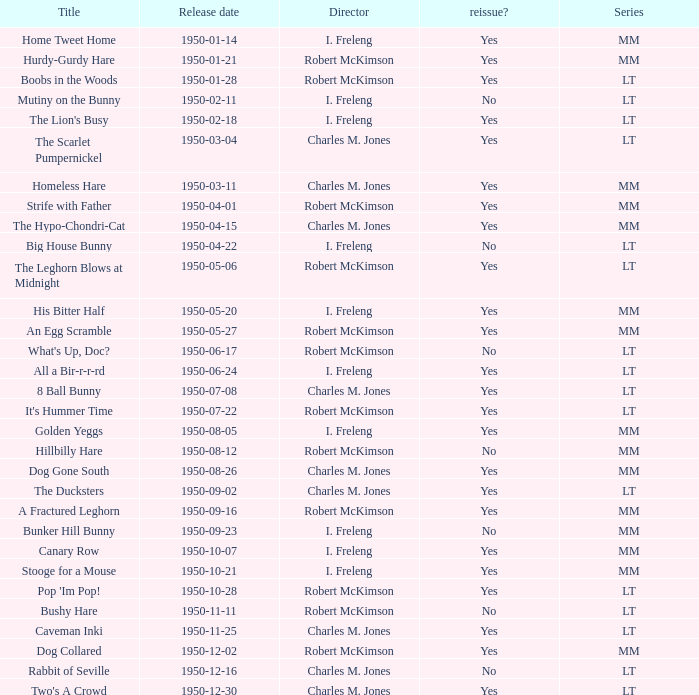Who directed An Egg Scramble? Robert McKimson. 